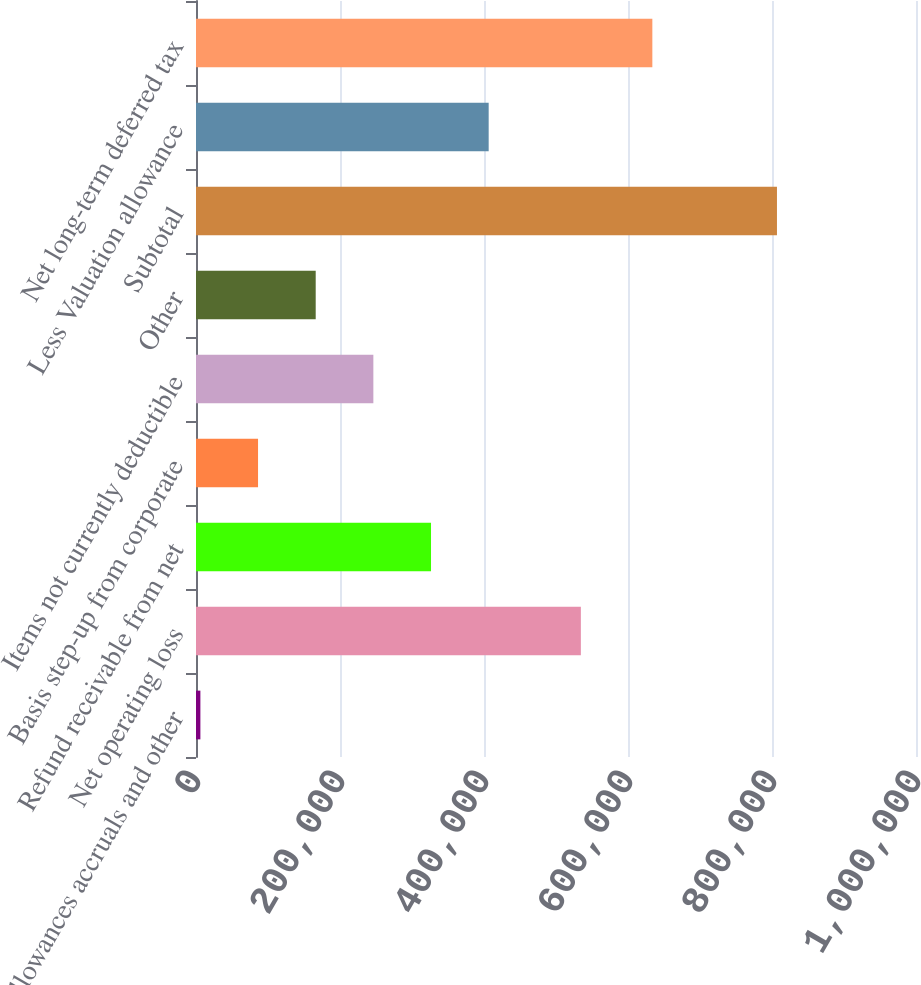Convert chart. <chart><loc_0><loc_0><loc_500><loc_500><bar_chart><fcel>Allowances accruals and other<fcel>Net operating loss<fcel>Refund receivable from net<fcel>Basis step-up from corporate<fcel>Items not currently deductible<fcel>Other<fcel>Subtotal<fcel>Less Valuation allowance<fcel>Net long-term deferred tax<nl><fcel>6090<fcel>534529<fcel>326410<fcel>86170.1<fcel>246330<fcel>166250<fcel>806891<fcel>406490<fcel>633814<nl></chart> 